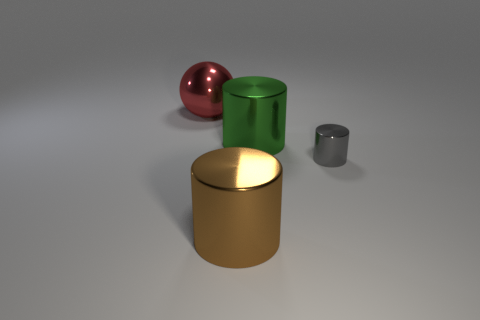Subtract all yellow cylinders. Subtract all blue spheres. How many cylinders are left? 3 Add 3 brown metallic things. How many objects exist? 7 Subtract all cylinders. How many objects are left? 1 Add 1 big brown things. How many big brown things are left? 2 Add 4 big cylinders. How many big cylinders exist? 6 Subtract 1 red balls. How many objects are left? 3 Subtract all small yellow rubber objects. Subtract all tiny metal objects. How many objects are left? 3 